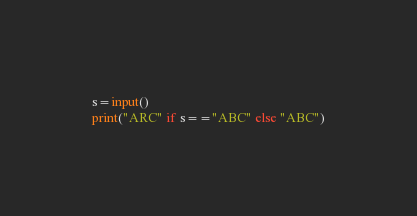Convert code to text. <code><loc_0><loc_0><loc_500><loc_500><_Python_>s=input()
print("ARC" if s=="ABC" else "ABC")</code> 